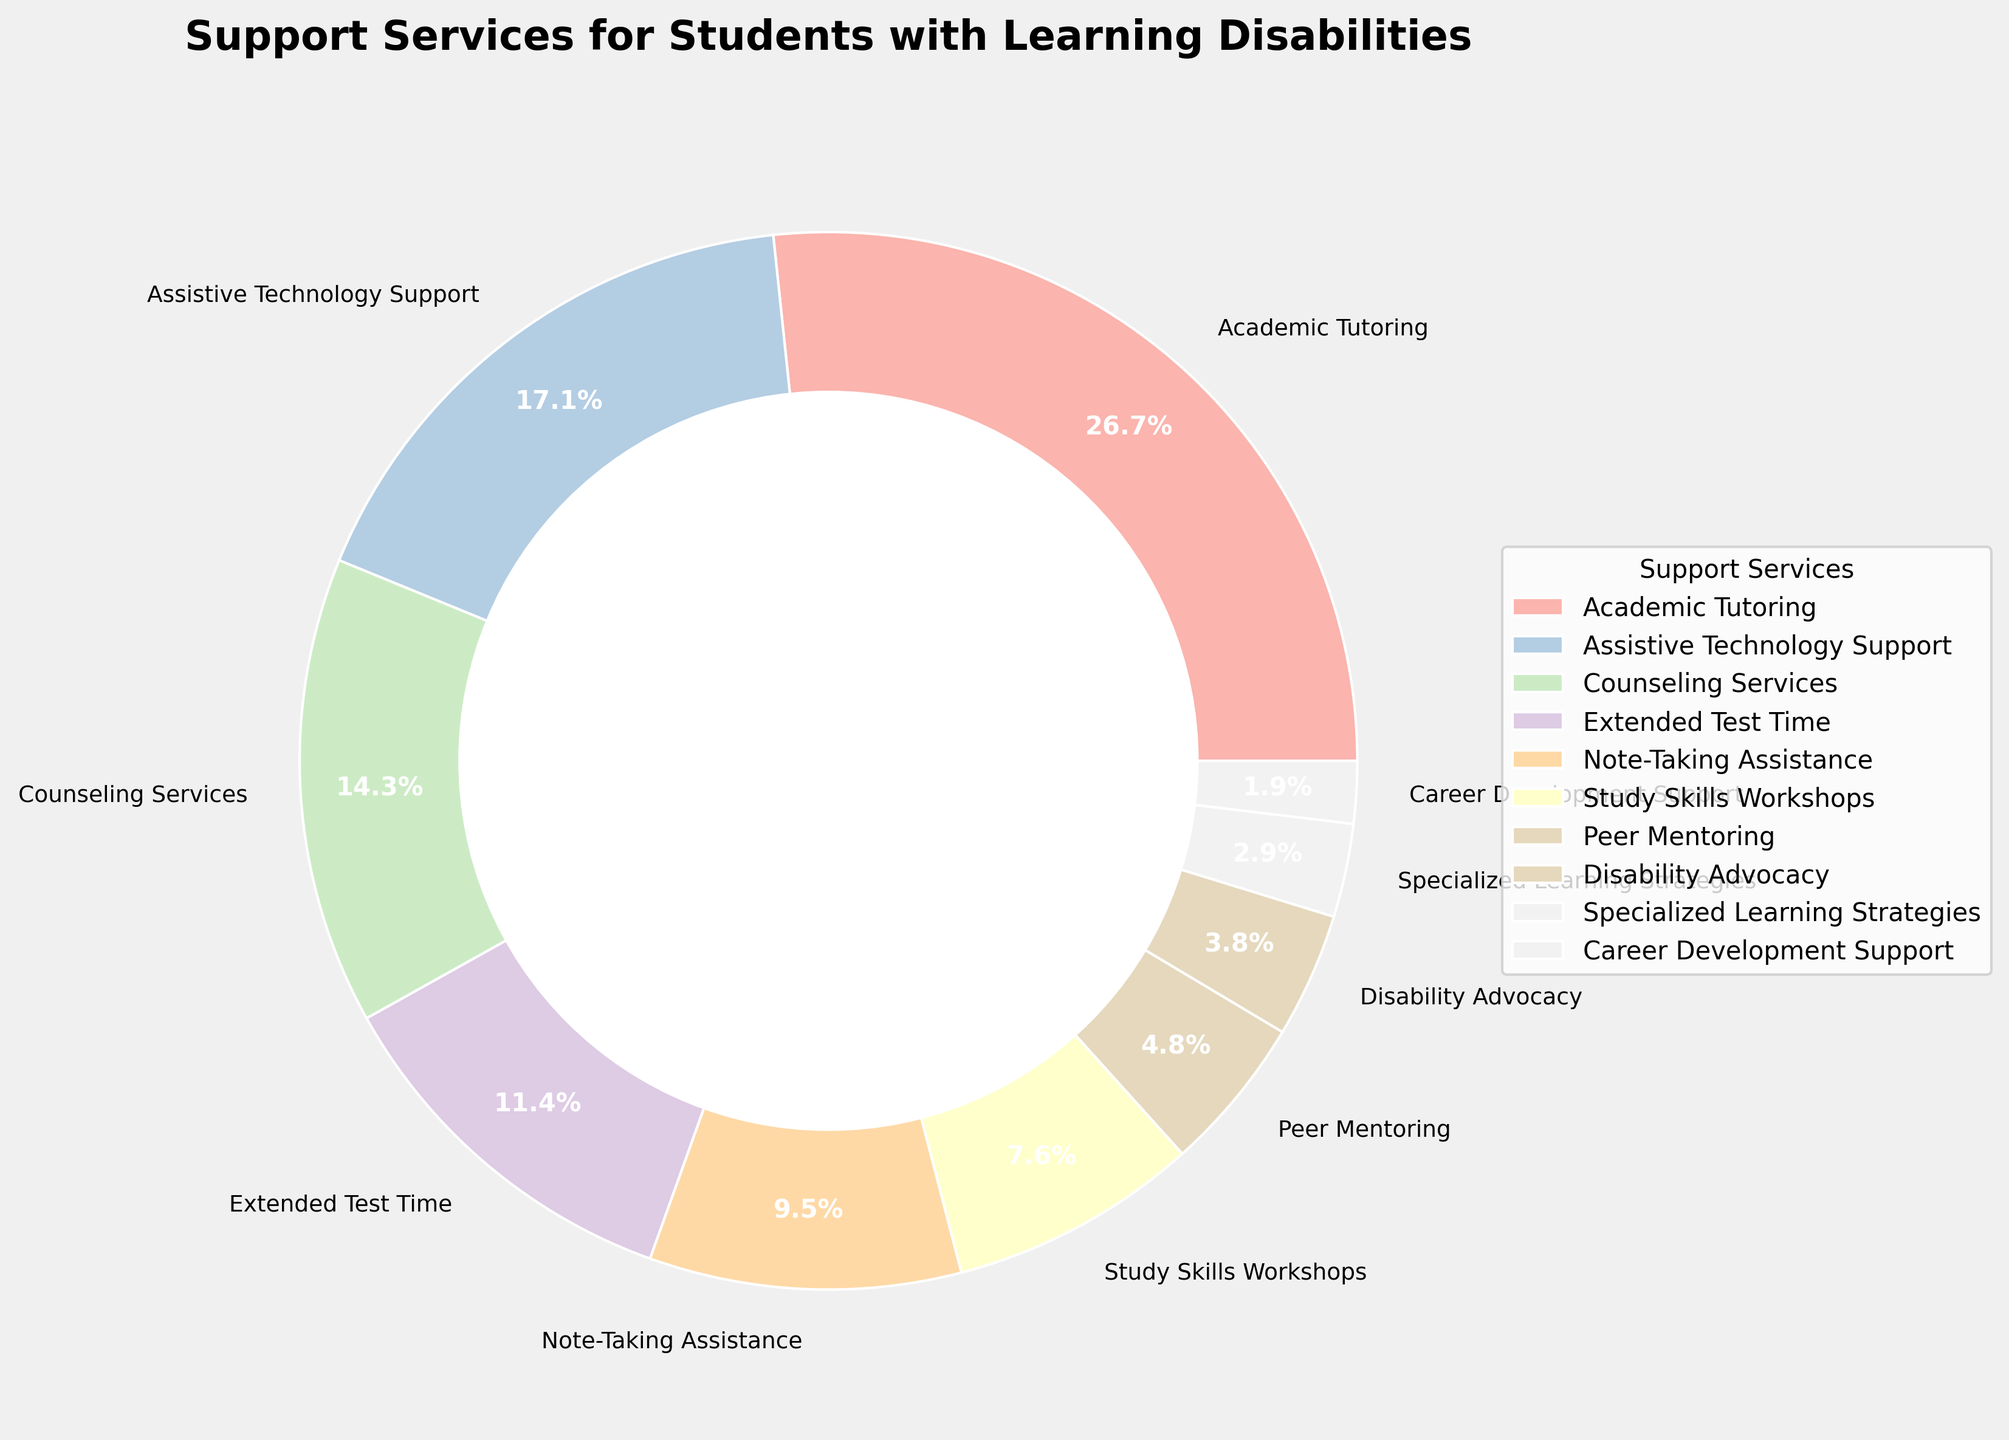What percentage of students use Academic Tutoring and Assistive Technology Support combined? Add the percentages for Academic Tutoring (28%) and Assistive Technology Support (18%): 28% + 18% = 46%.
Answer: 46% Which support service has the smallest percentage of use? The service with the smallest percentage is Career Development Support at 2%.
Answer: Career Development Support Are there more students using Note-Taking Assistance or Study Skills Workshops? Compare the percentages for Note-Taking Assistance (10%) and Study Skills Workshops (8%). 10% is greater than 8%.
Answer: Note-Taking Assistance What is the total percentage of students using Extended Test Time and Note-Taking Assistance? Add the percentages for Extended Test Time (12%) and Note-Taking Assistance (10%): 12% + 10% = 22%.
Answer: 22% How does the use of Peer Mentoring compare to Disability Advocacy? Compare the percentages: Peer Mentoring is at 5% and Disability Advocacy is at 4%, so Peer Mentoring is used more.
Answer: Peer Mentoring What percentage of students use Study Skills Workshops, and how does this compare to the use of extended test time? Study Skills Workshops are at 8% and Extended Test Time is at 12%. 8% is less than 12%.
Answer: Study Skills Workshops are less What is the combined percentage of students using Counseling Services and Career Development Support? Add the percentages for Counseling Services (15%) and Career Development Support (2%): 15% + 2% = 17%.
Answer: 17% Which service is used more, Academic Tutoring or Counseling Services, and by how much? Compare the percentages for Academic Tutoring (28%) and Counseling Services (15%). The difference is 28% - 15% = 13%.
Answer: Academic Tutoring by 13% Do Assistive Technology Support and Specialized Learning Strategies together make up more than 20%? Add the percentages for Assistive Technology Support (18%) and Specialized Learning Strategies (3%): 18% + 3% = 21%. This is more than 20%.
Answer: Yes 